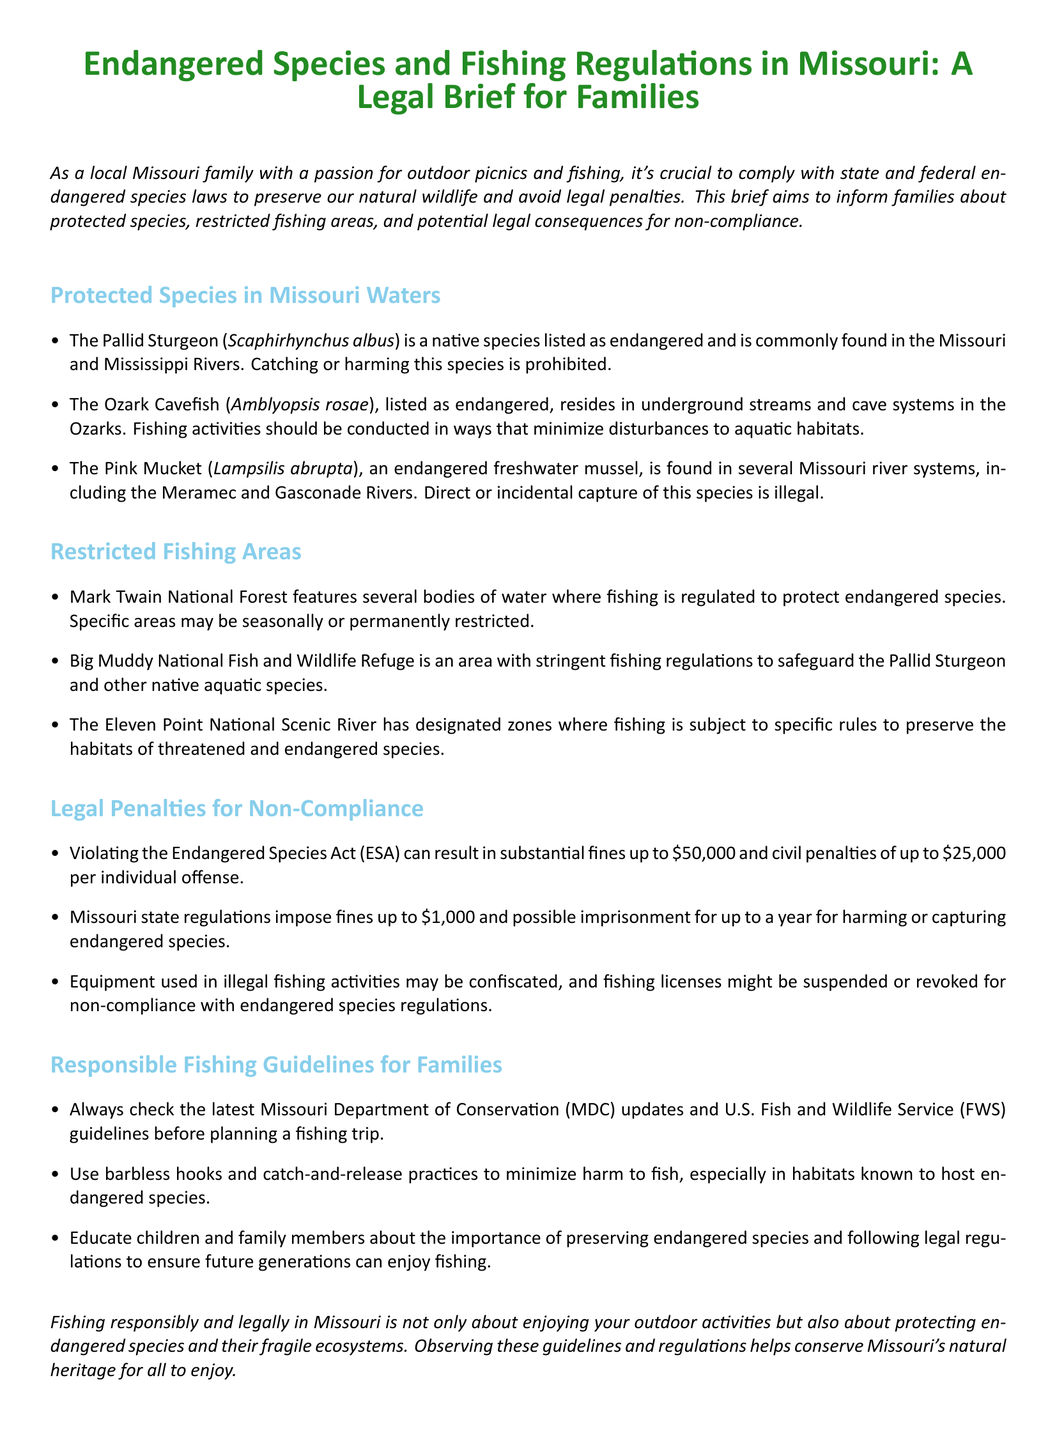what is the endangered species found in the Missouri and Mississippi Rivers? The document specifies that the Pallid Sturgeon is a native species listed as endangered and commonly found in these rivers.
Answer: Pallid Sturgeon what is the fine for violating the Endangered Species Act? The document indicates that violating the Endangered Species Act can result in substantial fines up to $50,000.
Answer: $50,000 which area has stringent fishing regulations to safeguard the Pallid Sturgeon? The document states that the Big Muddy National Fish and Wildlife Refuge is an area with stringent fishing regulations for this purpose.
Answer: Big Muddy National Fish and Wildlife Refuge how much can fines be for harming or capturing endangered species in Missouri? According to the document, Missouri state regulations impose fines up to $1,000 for these offenses.
Answer: $1,000 what fishing practice is recommended to minimize harm to fish? The document advises using barbless hooks and catch-and-release practices to minimize harm to fish.
Answer: barbless hooks and catch-and-release practices what is the primary focus of the legal brief? The legal brief is focused on informing families about protected species, restricted fishing areas, and consequences of non-compliance with endangered species laws.
Answer: informing families about protected species, restricted fishing areas, and consequences of non-compliance which document provides guidelines before planning a fishing trip? The document mentions that families should check the latest updates from the Missouri Department of Conservation (MDC) and U.S. Fish and Wildlife Service (FWS).
Answer: Missouri Department of Conservation and U.S. Fish and Wildlife Service what can happen to fishing licenses for non-compliance with regulations? The document states that fishing licenses might be suspended or revoked for non-compliance with endangered species regulations.
Answer: suspended or revoked 